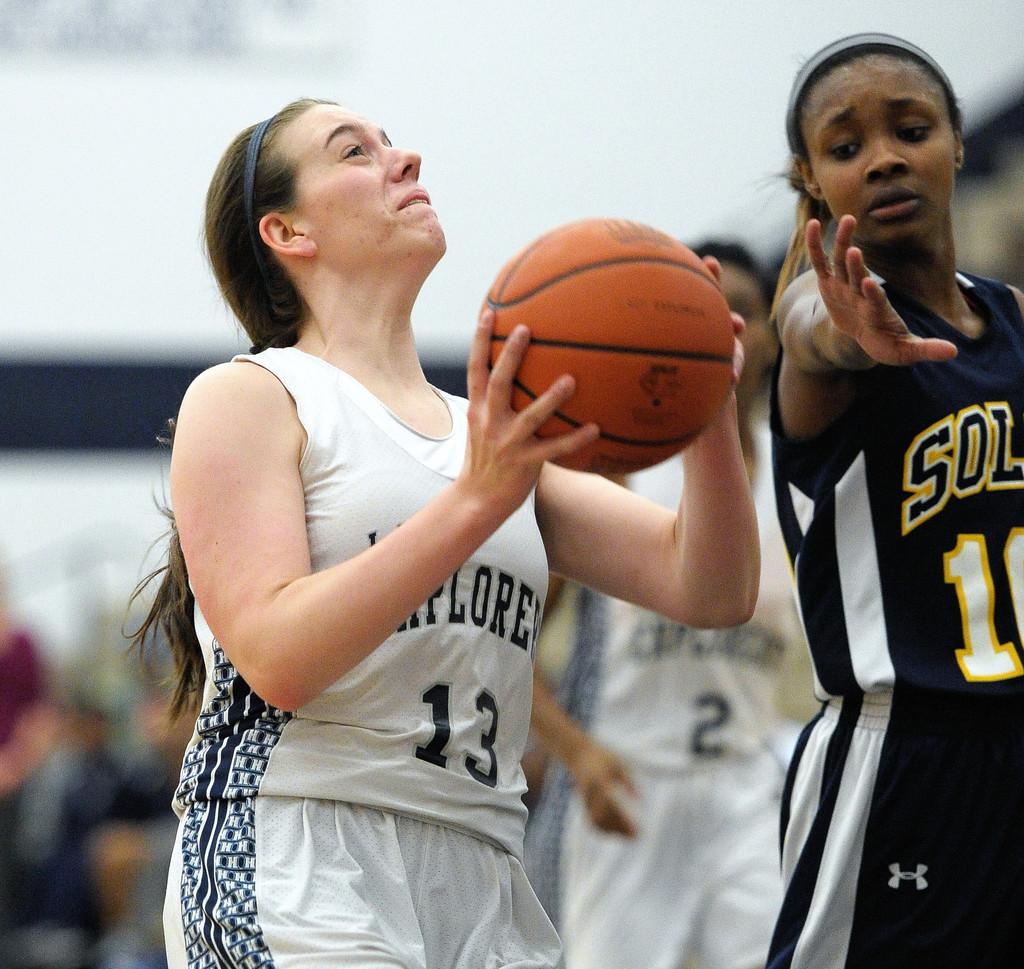Which player has the ball?
Offer a very short reply. 13. 